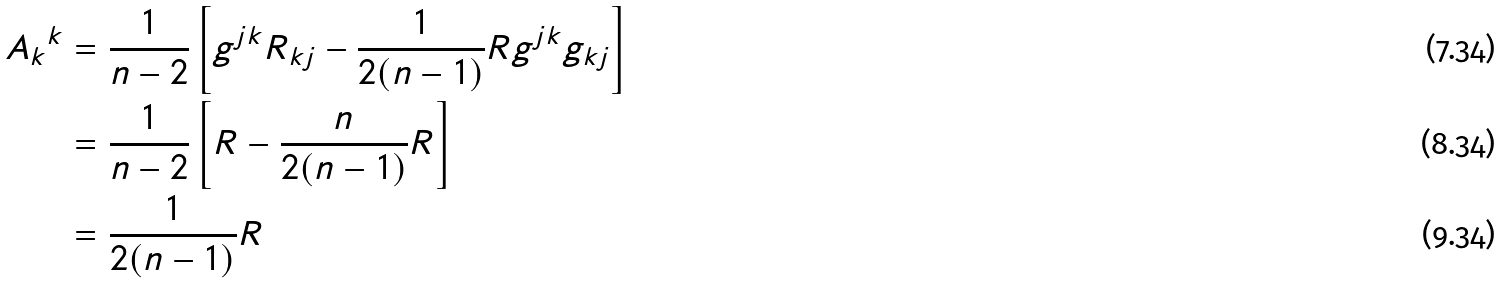Convert formula to latex. <formula><loc_0><loc_0><loc_500><loc_500>{ A _ { k } } ^ { k } & = \frac { 1 } { n - 2 } \left [ g ^ { j k } R _ { k j } - \frac { 1 } { 2 ( n - 1 ) } R g ^ { j k } g _ { k j } \right ] \\ & = \frac { 1 } { n - 2 } \left [ R - \frac { n } { 2 ( n - 1 ) } R \right ] \\ & = \frac { 1 } { 2 ( n - 1 ) } R</formula> 